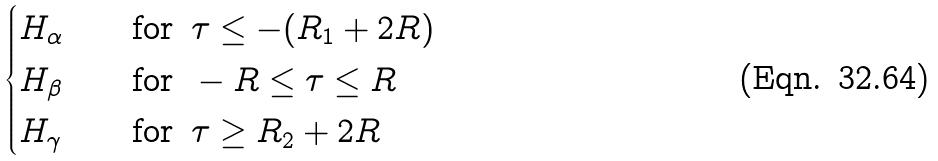<formula> <loc_0><loc_0><loc_500><loc_500>\begin{cases} H _ { \alpha } \quad & \text {for } \, \tau \leq - ( R _ { 1 } + 2 R ) \\ H _ { \beta } \quad & \text {for } \, - R \leq \tau \leq R \\ H _ { \gamma } \quad & \text {for } \, \tau \geq R _ { 2 } + 2 R \end{cases}</formula> 